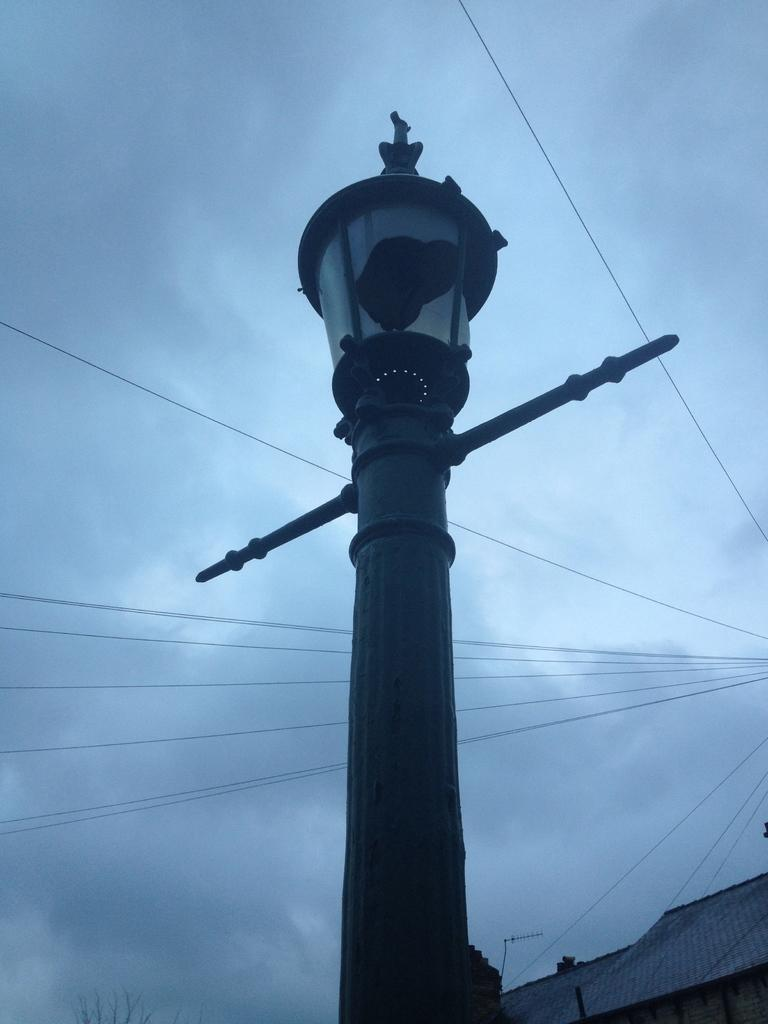What is the main object in the center of the image? There is a pole with a light in the center of the image. What structures are visible at the bottom of the image? There is a roof, a tree, and a wall visible at the bottom of the image. What can be seen in the background of the image? Wires and clouds are present in the background of the image. Can you tell me how many toys are on the roof in the image? There are no toys present in the image; it features a pole with a light, a roof, a tree, a wall, wires, and clouds. 